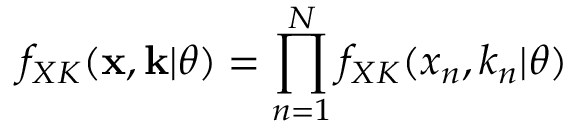<formula> <loc_0><loc_0><loc_500><loc_500>f _ { X K } ( \mathbf x , \mathbf k | \theta ) = \prod _ { n = 1 } ^ { N } f _ { X K } ( x _ { n } , k _ { n } | \theta )</formula> 